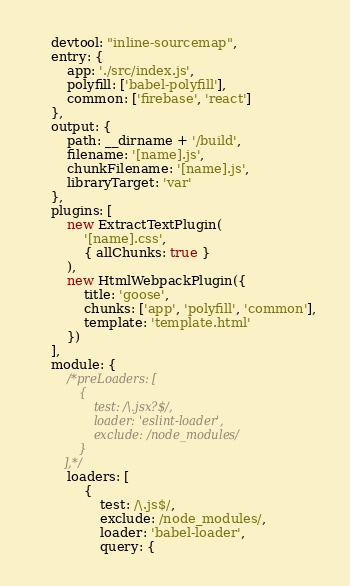<code> <loc_0><loc_0><loc_500><loc_500><_JavaScript_>    devtool: "inline-sourcemap",
    entry: {
        app: './src/index.js',
        polyfill: ['babel-polyfill'],
        common: ['firebase', 'react']
    },
    output: {
        path: __dirname + '/build',
        filename: '[name].js',
        chunkFilename: '[name].js',
        libraryTarget: 'var'
    },
    plugins: [
        new ExtractTextPlugin(
            '[name].css',
            { allChunks: true }
        ),
        new HtmlWebpackPlugin({
            title: 'goose',
            chunks: ['app', 'polyfill', 'common'],
            template: 'template.html'
        })
    ],
    module: {
        /*preLoaders: [
            {
                test: /\.jsx?$/,
                loader: 'eslint-loader',
                exclude: /node_modules/
            }
        ],*/
        loaders: [
            {
                test: /\.js$/,
                exclude: /node_modules/,
                loader: 'babel-loader',
                query: {</code> 